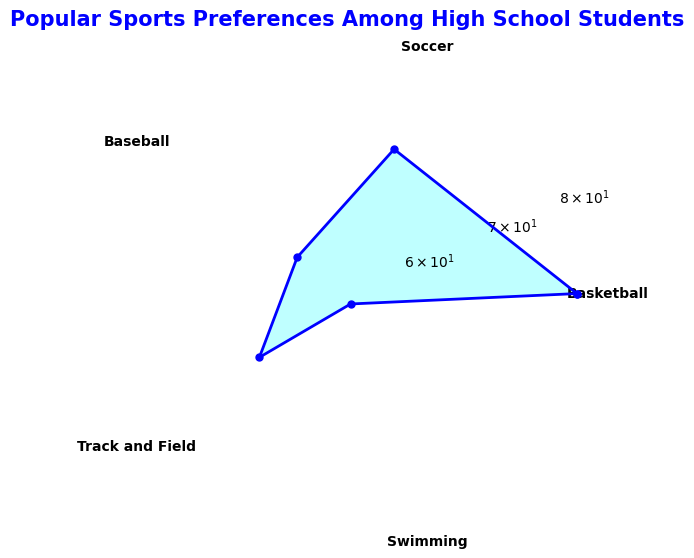What's the most popular sport among high school students? By examining the radar chart, we look for the sport with the highest value on the radial scale. The peak value corresponds to Basketball.
Answer: Basketball Which sport has the lowest popularity among high school students? By observing the radar chart, we identify the sport with the shortest length from the center. The minimum value corresponds to Swimming.
Answer: Swimming What is the difference in popularity between Basketball and Swimming? First, determine the popularity values for Basketball (80) and Swimming (55). Next, subtract the lower value from the higher value: \(80 - 55 = 25\).
Answer: 25 Rank the sports from most to least popular. From the radar chart, list the sports in descending order of their values: Basketball (80), Soccer (70), Track and Field (65), Baseball (60), and Swimming (55).
Answer: Basketball, Soccer, Track and Field, Baseball, Swimming What is the average popularity score of all the sports? Sum the popularity values: \(80 + 70 + 60 + 65 + 55 = 330\). Then, divide by the number of sports (5): \(330 / 5 = 66\).
Answer: 66 How much more popular is Soccer compared to Baseball? Identify the popularity values for Soccer (70) and Baseball (60). Subtract the lower value from the higher value: \(70 - 60 = 10\).
Answer: 10 Which sport ranks third in terms of popularity? By ranking the sports based on their values from the radar chart, the third highest is Track and Field with a value of 65.
Answer: Track and Field What is the sum of the popularity values for Basketball and Soccer? Add the popularity values for Basketball (80) and Soccer (70): \(80 + 70 = 150\).
Answer: 150 Is Track and Field more popular than Baseball? By comparing their values on the radar chart, Track and Field (65) has a higher value than Baseball (60).
Answer: Yes Which two sports have a combined popularity greater than 130? By testing combinations: Basketball (80) and Soccer (70) together make \(80 + 70 = 150\), which is greater than 130.
Answer: Basketball and Soccer 